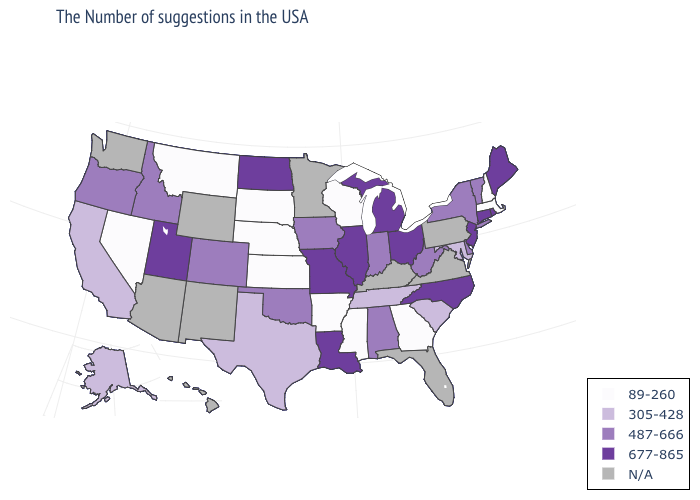Name the states that have a value in the range 305-428?
Short answer required. Maryland, South Carolina, Tennessee, Texas, California, Alaska. Does the map have missing data?
Concise answer only. Yes. Name the states that have a value in the range N/A?
Quick response, please. Pennsylvania, Virginia, Florida, Kentucky, Minnesota, Wyoming, New Mexico, Arizona, Washington, Hawaii. Name the states that have a value in the range 677-865?
Be succinct. Maine, Rhode Island, Connecticut, New Jersey, North Carolina, Ohio, Michigan, Illinois, Louisiana, Missouri, North Dakota, Utah. Does the first symbol in the legend represent the smallest category?
Be succinct. Yes. Among the states that border Oregon , does California have the lowest value?
Give a very brief answer. No. Name the states that have a value in the range 487-666?
Be succinct. Vermont, New York, Delaware, West Virginia, Indiana, Alabama, Iowa, Oklahoma, Colorado, Idaho, Oregon. What is the value of Connecticut?
Quick response, please. 677-865. What is the value of Missouri?
Keep it brief. 677-865. What is the value of Arkansas?
Give a very brief answer. 89-260. What is the value of Alaska?
Be succinct. 305-428. Name the states that have a value in the range 487-666?
Keep it brief. Vermont, New York, Delaware, West Virginia, Indiana, Alabama, Iowa, Oklahoma, Colorado, Idaho, Oregon. Among the states that border Alabama , does Tennessee have the lowest value?
Answer briefly. No. Which states hav the highest value in the MidWest?
Concise answer only. Ohio, Michigan, Illinois, Missouri, North Dakota. 